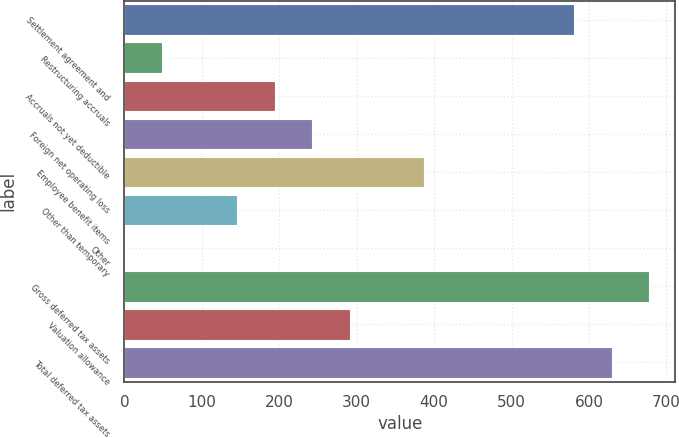Convert chart to OTSL. <chart><loc_0><loc_0><loc_500><loc_500><bar_chart><fcel>Settlement agreement and<fcel>Restructuring accruals<fcel>Accruals not yet deductible<fcel>Foreign net operating loss<fcel>Employee benefit items<fcel>Other than temporary<fcel>Other<fcel>Gross deferred tax assets<fcel>Valuation allowance<fcel>Total deferred tax assets<nl><fcel>580.94<fcel>48.87<fcel>193.98<fcel>242.35<fcel>387.46<fcel>145.61<fcel>0.5<fcel>677.68<fcel>290.72<fcel>629.31<nl></chart> 